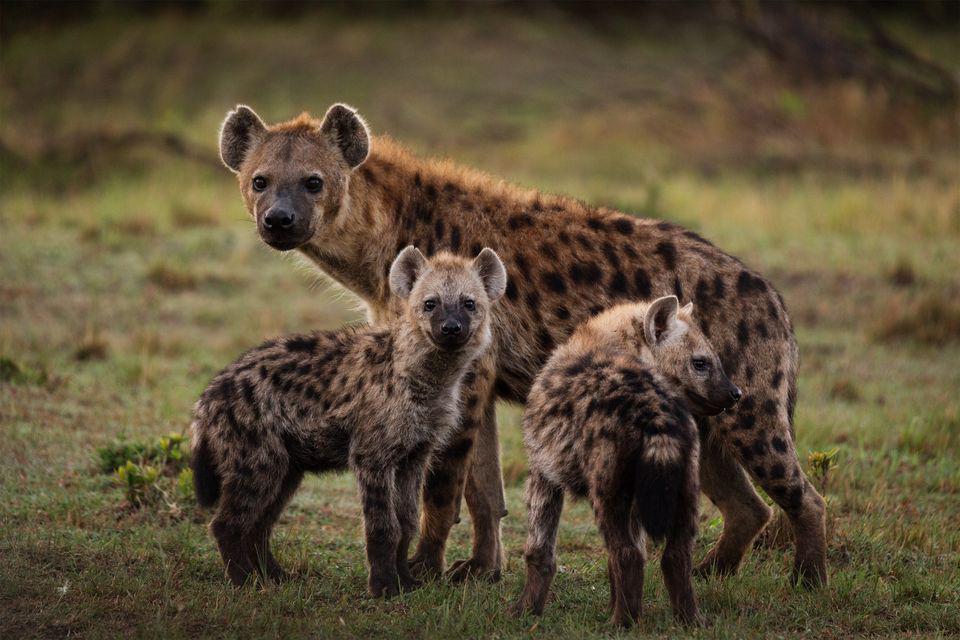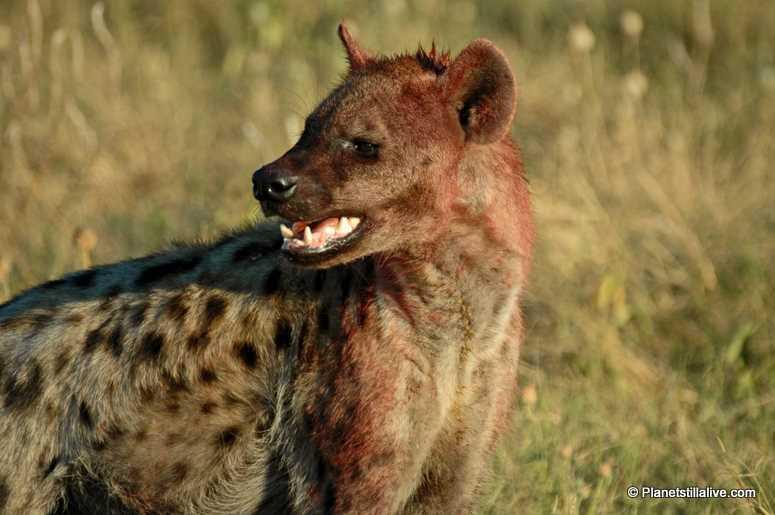The first image is the image on the left, the second image is the image on the right. For the images displayed, is the sentence "The left image contains no more than two hyenas." factually correct? Answer yes or no. No. The first image is the image on the left, the second image is the image on the right. For the images shown, is this caption "There is at least one hyena with its mouth closed." true? Answer yes or no. Yes. 